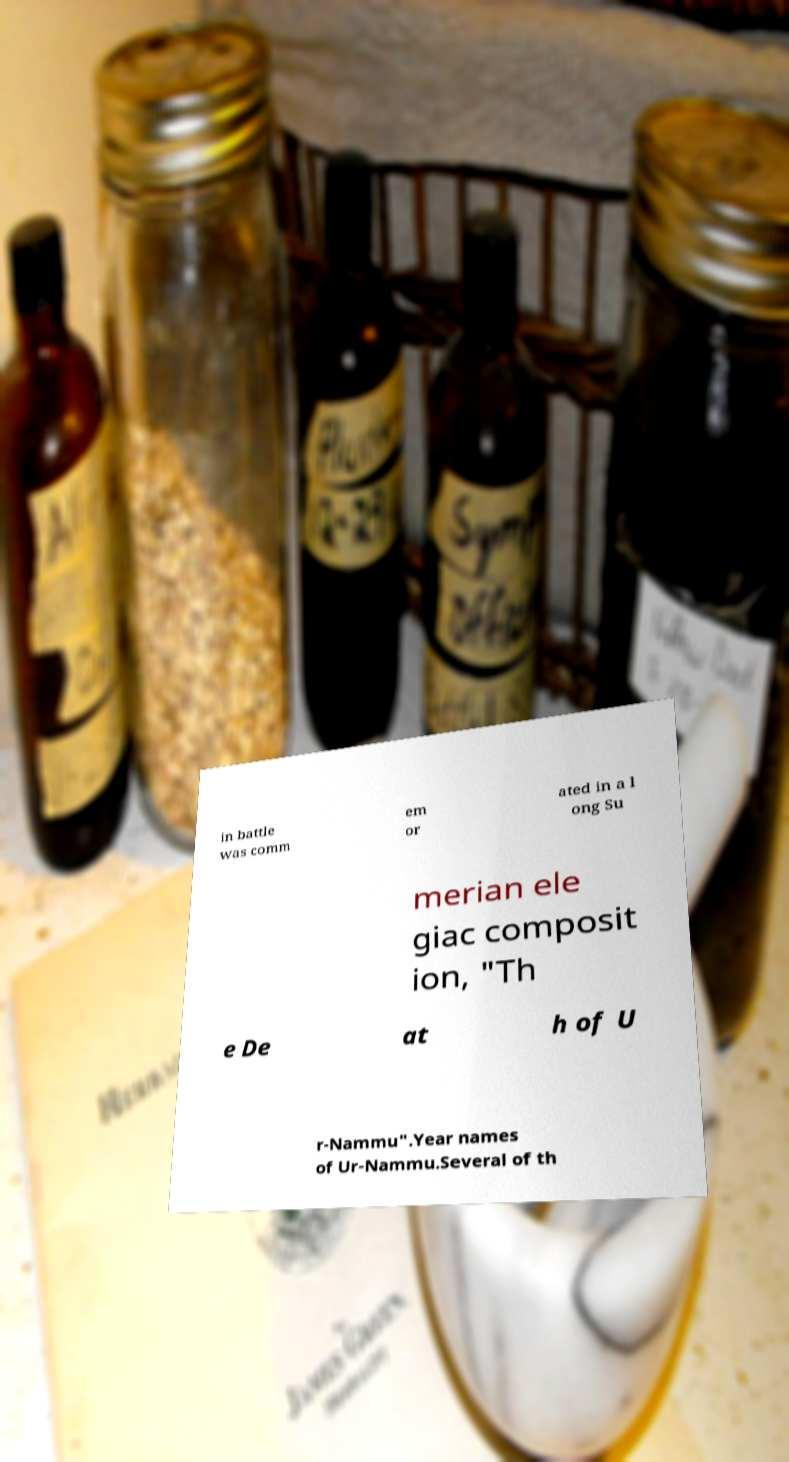There's text embedded in this image that I need extracted. Can you transcribe it verbatim? in battle was comm em or ated in a l ong Su merian ele giac composit ion, "Th e De at h of U r-Nammu".Year names of Ur-Nammu.Several of th 